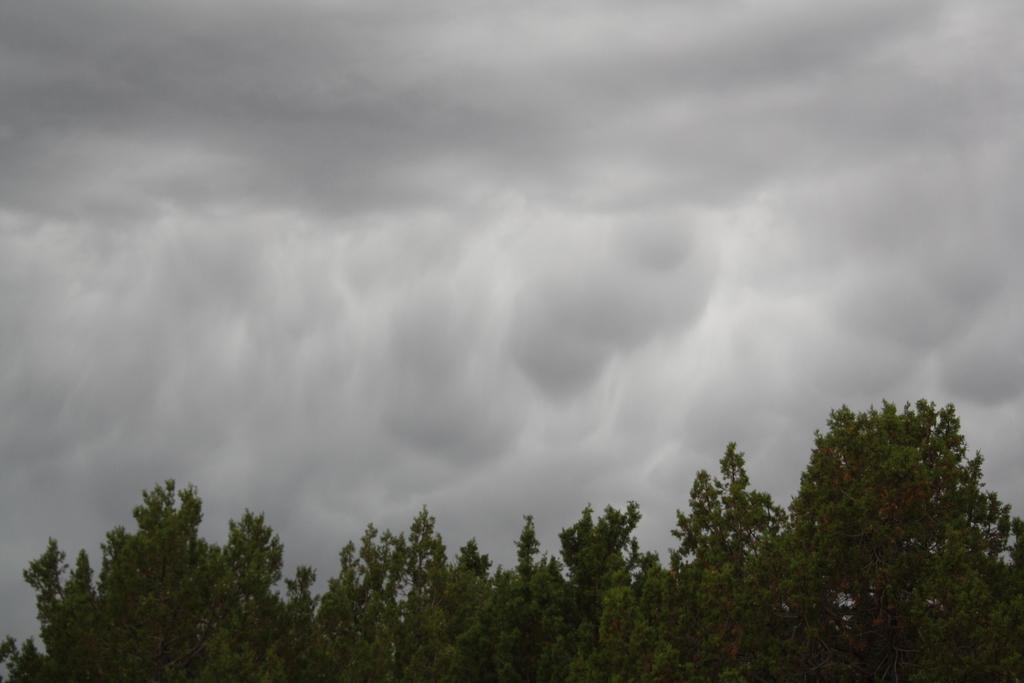Can you describe this image briefly? At the bottom of the picture, there are trees. At the top of the picture, we see the sky. 